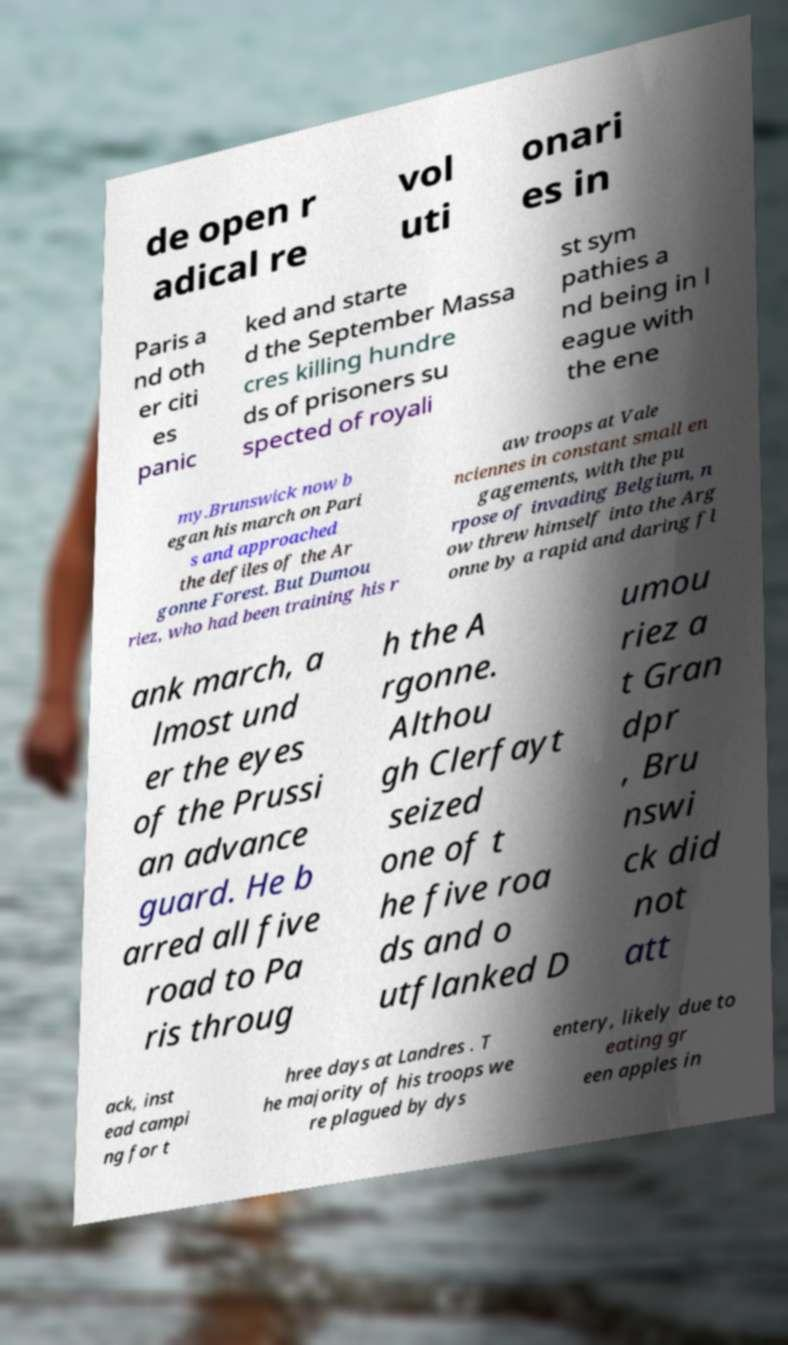Please read and relay the text visible in this image. What does it say? de open r adical re vol uti onari es in Paris a nd oth er citi es panic ked and starte d the September Massa cres killing hundre ds of prisoners su spected of royali st sym pathies a nd being in l eague with the ene my.Brunswick now b egan his march on Pari s and approached the defiles of the Ar gonne Forest. But Dumou riez, who had been training his r aw troops at Vale nciennes in constant small en gagements, with the pu rpose of invading Belgium, n ow threw himself into the Arg onne by a rapid and daring fl ank march, a lmost und er the eyes of the Prussi an advance guard. He b arred all five road to Pa ris throug h the A rgonne. Althou gh Clerfayt seized one of t he five roa ds and o utflanked D umou riez a t Gran dpr , Bru nswi ck did not att ack, inst ead campi ng for t hree days at Landres . T he majority of his troops we re plagued by dys entery, likely due to eating gr een apples in 